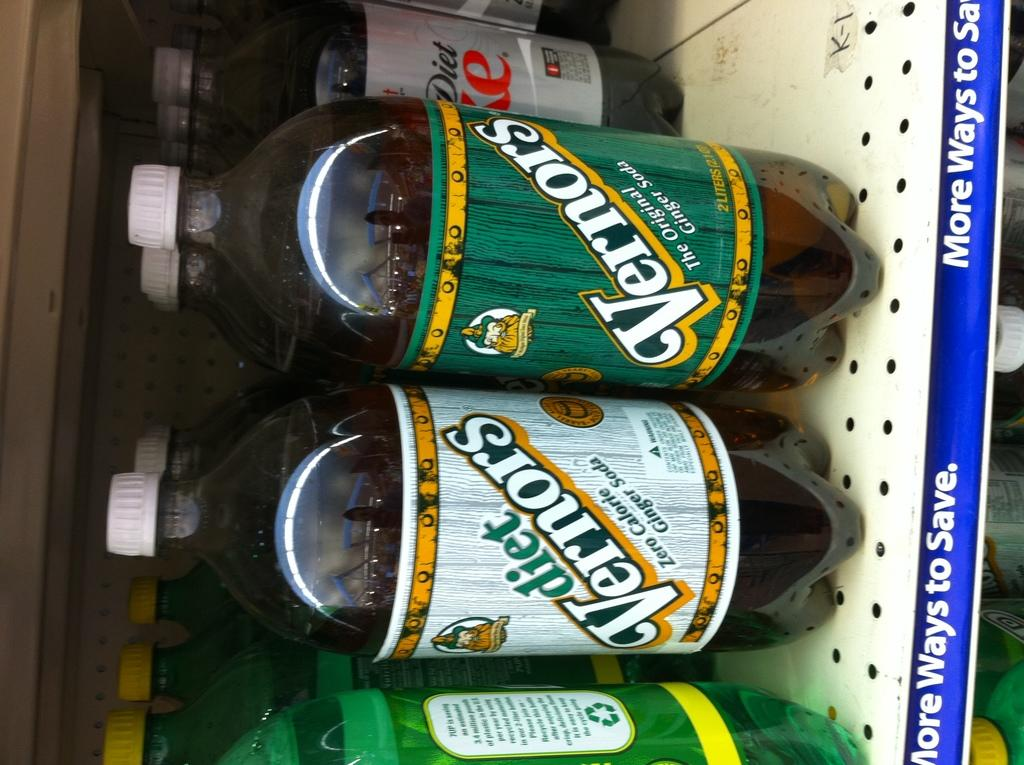<image>
Relay a brief, clear account of the picture shown. A shelf has bottles for Vernors and diet Vernors ginger soda. 